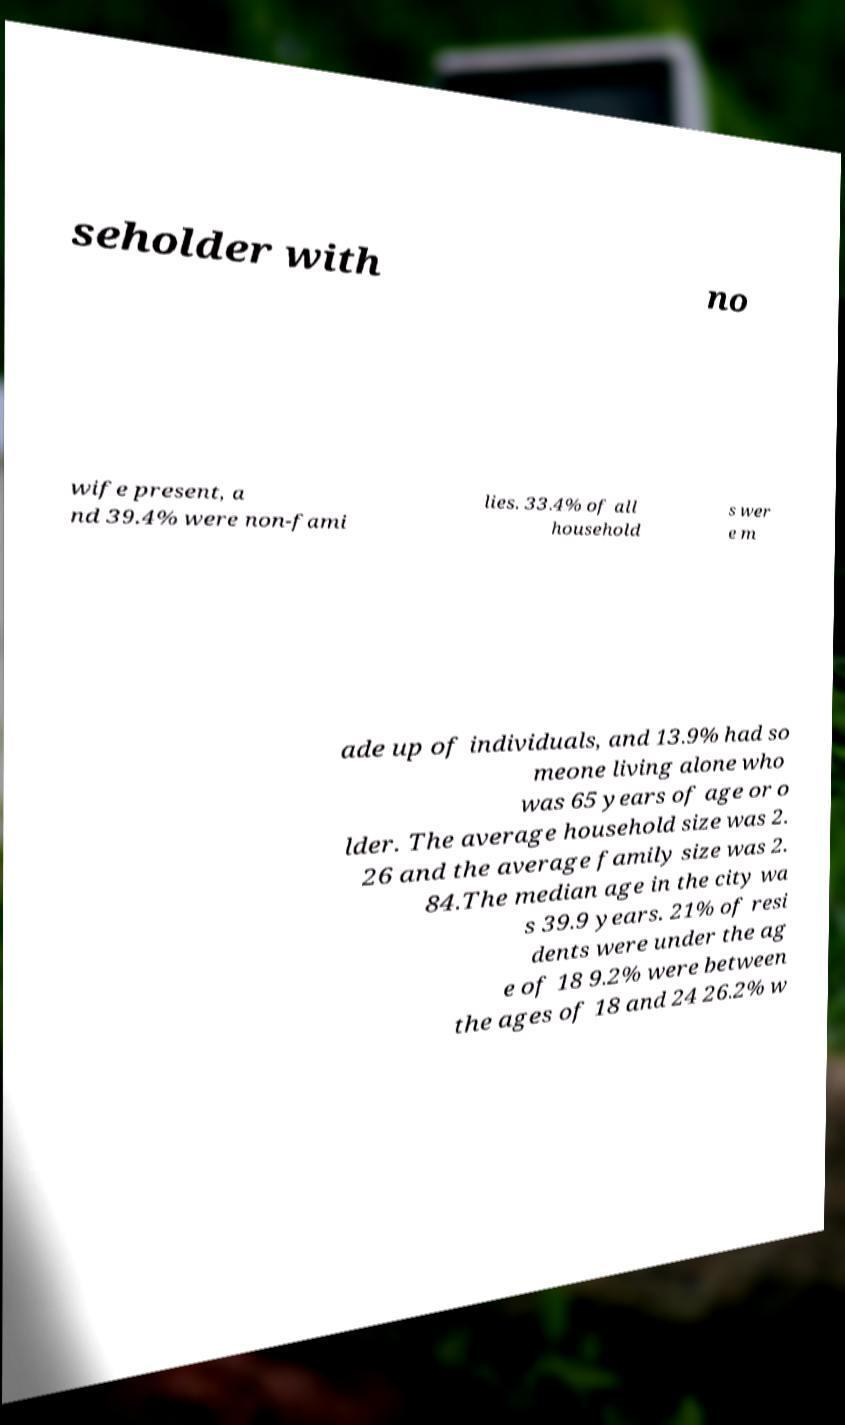What messages or text are displayed in this image? I need them in a readable, typed format. seholder with no wife present, a nd 39.4% were non-fami lies. 33.4% of all household s wer e m ade up of individuals, and 13.9% had so meone living alone who was 65 years of age or o lder. The average household size was 2. 26 and the average family size was 2. 84.The median age in the city wa s 39.9 years. 21% of resi dents were under the ag e of 18 9.2% were between the ages of 18 and 24 26.2% w 